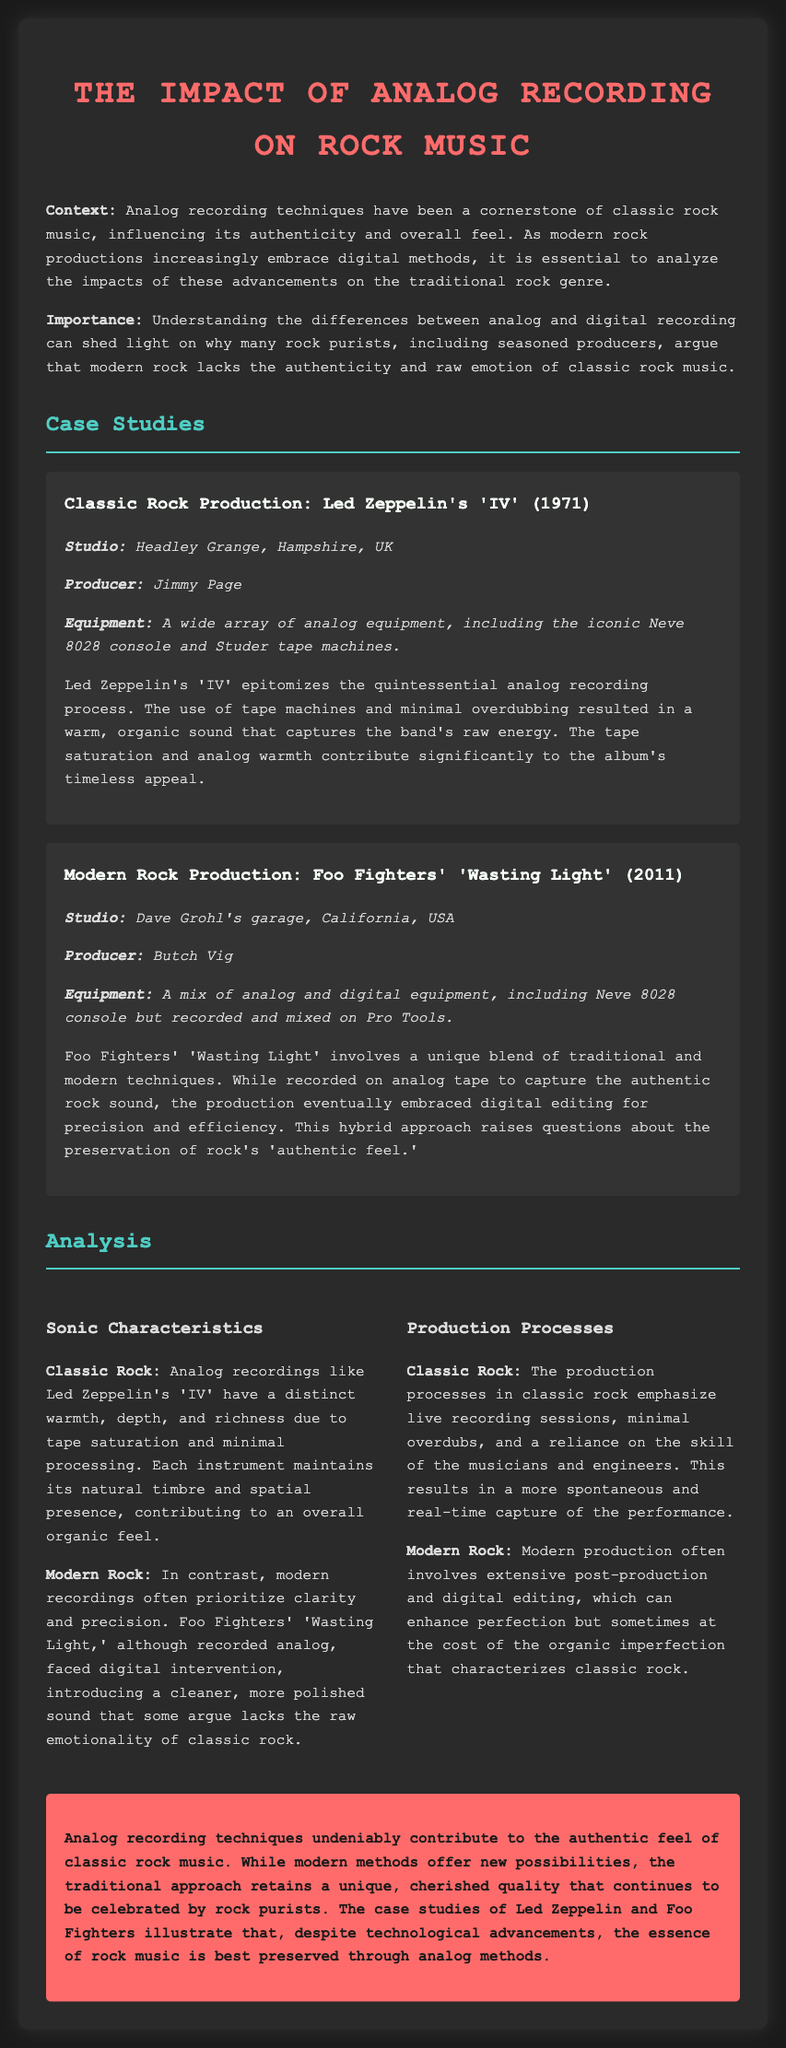What is the main context discussed in the document? The document discusses the impact of analog recording techniques on the authenticity and feel of rock music compared to modern productions.
Answer: Analog recording techniques Who produced Led Zeppelin's 'IV'? The document states the producer of Led Zeppelin's 'IV' as Jimmy Page.
Answer: Jimmy Page What studio was used to record Foo Fighters' 'Wasting Light'? The document mentions that Foo Fighters' 'Wasting Light' was recorded in Dave Grohl's garage.
Answer: Dave Grohl's garage What equipment was primarily used in the recording of Led Zeppelin's 'IV'? The document specifies that Led Zeppelin's 'IV' used a Neve 8028 console and Studer tape machines.
Answer: Neve 8028 console and Studer tape machines How does the document describe the sonic characteristics of classic rock? The sonic characteristics of classic rock are described as having warmth, depth, and richness due to tape saturation.
Answer: Warmth, depth, richness What is a key feature of the production process in classic rock? The document notes that classic rock production emphasizes live recording sessions and minimal overdubs.
Answer: Live recording sessions and minimal overdubs What compromise is raised about modern rock production methods? The document discusses the compromise of clarity and precision potentially lacking the raw emotionality found in classic rock.
Answer: Lack of raw emotionality What is the conclusion regarding analog recording techniques? The conclusion asserts that analog recording techniques contribute significantly to the authentic feel of classic rock.
Answer: Authentic feel of classic rock What hybrid approach is mentioned in relation to Foo Fighters' recording methods? The document states that Foo Fighters' recording involved a blend of traditional and modern techniques.
Answer: Blend of traditional and modern techniques 